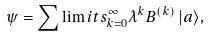<formula> <loc_0><loc_0><loc_500><loc_500>\psi = \sum \lim i t s _ { k = 0 } ^ { \infty } \lambda ^ { k } B ^ { ( k ) } \, | a \rangle ,</formula> 